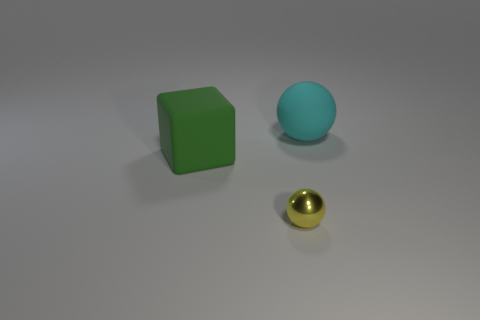How many big blocks are the same color as the tiny sphere?
Your response must be concise. 0. The cyan thing that is the same size as the green rubber cube is what shape?
Keep it short and to the point. Sphere. There is a yellow metallic thing; are there any green rubber things behind it?
Offer a terse response. Yes. Do the green block and the rubber ball have the same size?
Ensure brevity in your answer.  Yes. What shape is the matte thing behind the block?
Your answer should be very brief. Sphere. Are there any cyan objects of the same size as the green thing?
Ensure brevity in your answer.  Yes. What is the material of the cyan thing that is the same size as the green rubber object?
Provide a succinct answer. Rubber. There is a sphere in front of the large cyan rubber object; what is its size?
Make the answer very short. Small. The matte sphere is what size?
Your answer should be compact. Large. There is a cyan matte thing; does it have the same size as the thing that is in front of the green rubber thing?
Make the answer very short. No. 